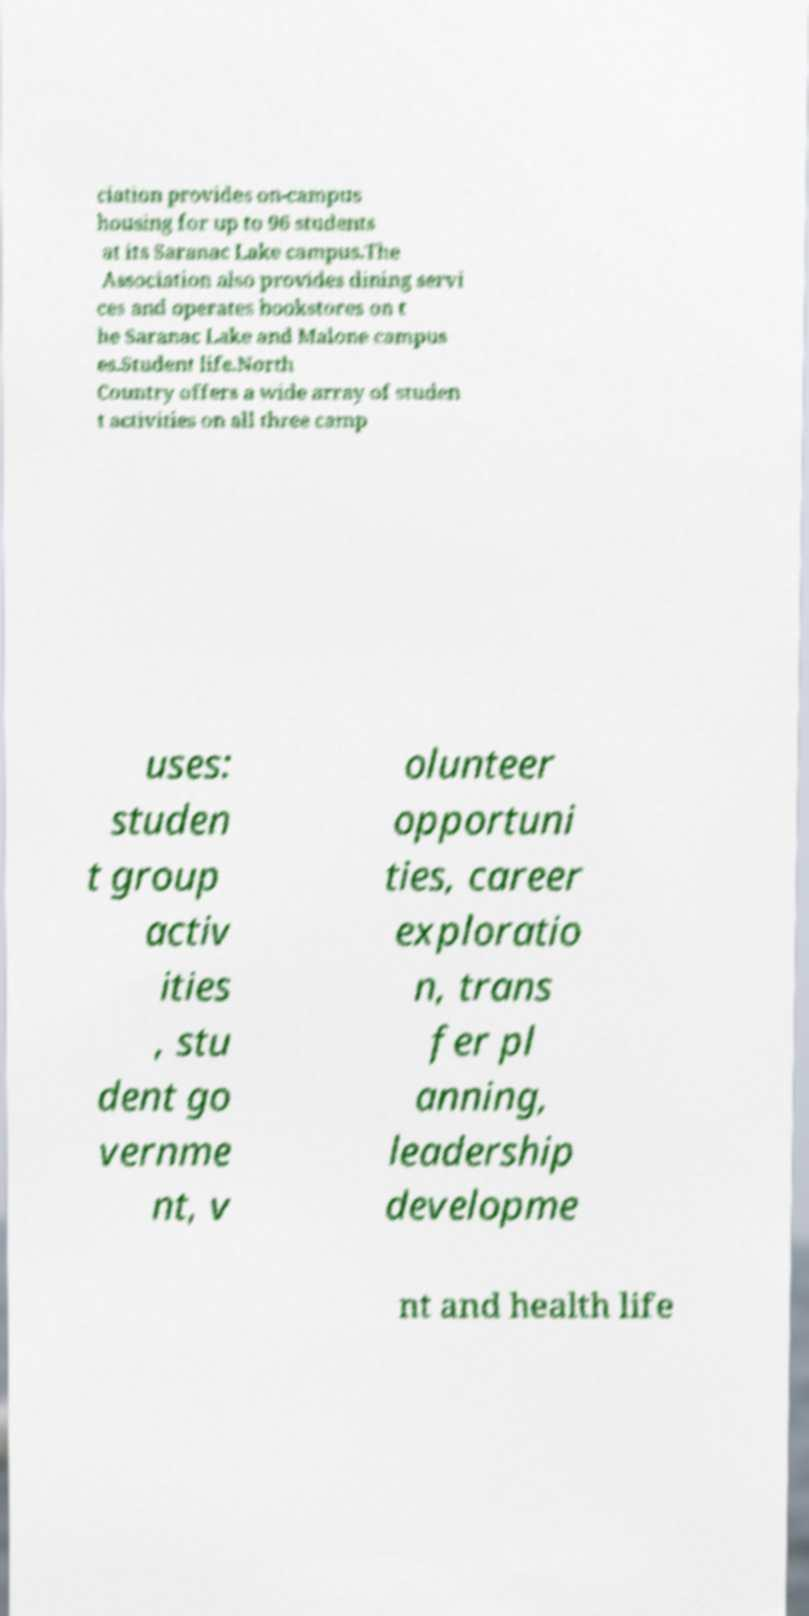Could you assist in decoding the text presented in this image and type it out clearly? ciation provides on-campus housing for up to 96 students at its Saranac Lake campus.The Association also provides dining servi ces and operates bookstores on t he Saranac Lake and Malone campus es.Student life.North Country offers a wide array of studen t activities on all three camp uses: studen t group activ ities , stu dent go vernme nt, v olunteer opportuni ties, career exploratio n, trans fer pl anning, leadership developme nt and health life 